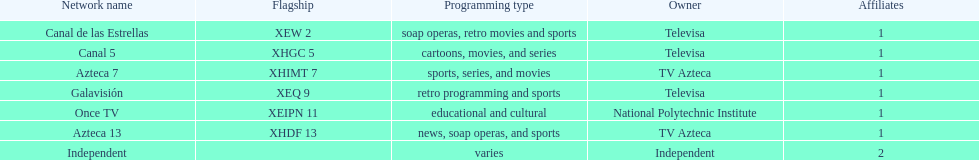What is the total number of affiliates among all the networks? 8. 